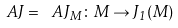Convert formula to latex. <formula><loc_0><loc_0><loc_500><loc_500>\ A J = \ A J _ { M } \colon M \to J _ { 1 } ( M )</formula> 